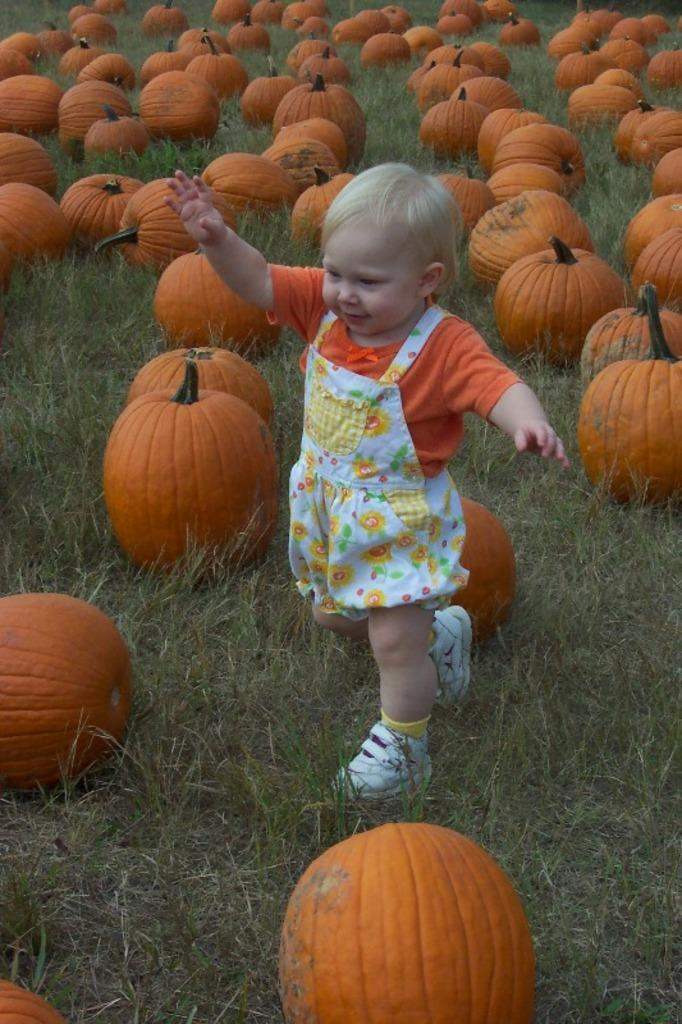What is the main subject of the image? The main subject of the image is a girl walking. What can be seen on the ground in the image? There are pumpkins on the grass in the image. What type of memory does the girl have in the image? There is no indication of a memory in the image; it simply shows a girl walking and pumpkins on the grass. 